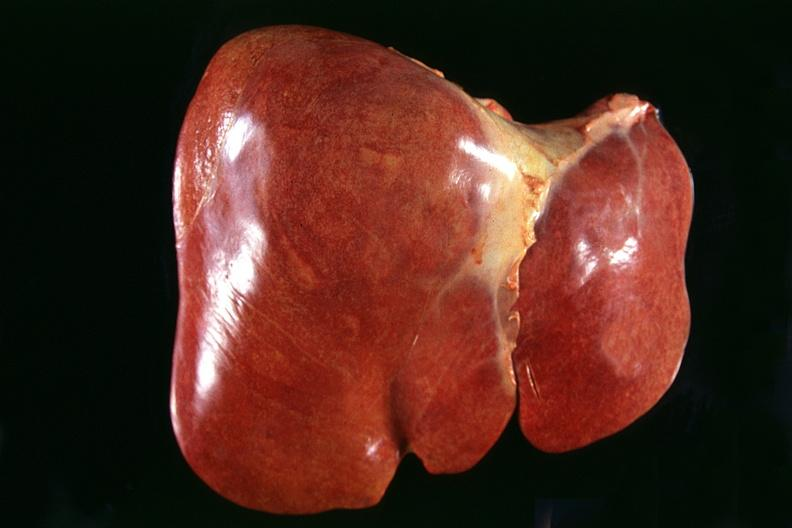what is present?
Answer the question using a single word or phrase. Hepatobiliary 